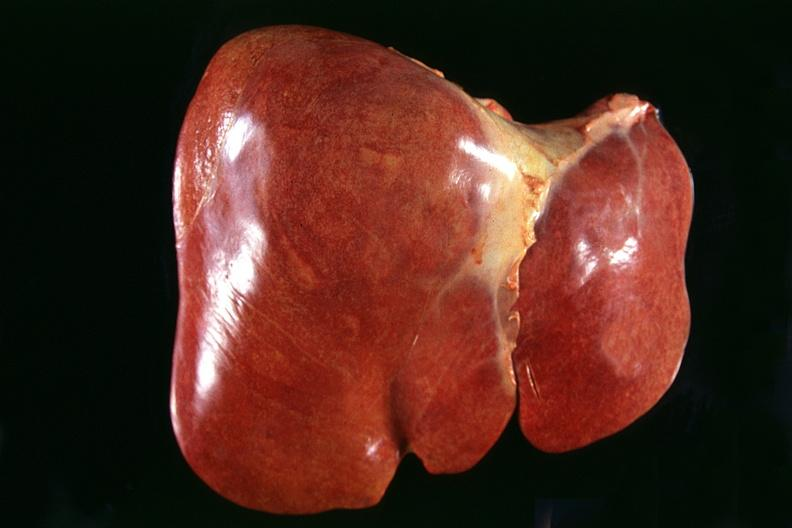what is present?
Answer the question using a single word or phrase. Hepatobiliary 